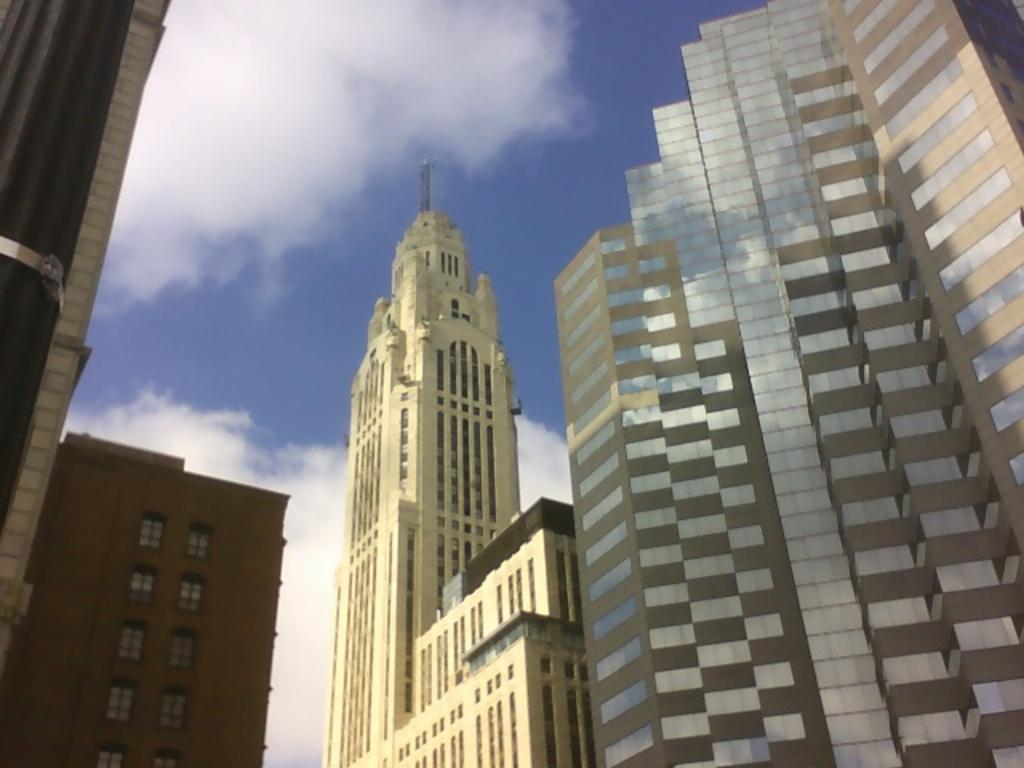What is located in the center of the image? There are buildings in the center of the image. What can be seen in the background of the image? The sky is visible in the background of the image. What type of steel is used to construct the buildings in the image? There is no information provided about the type of steel used in the construction of the buildings in the image. How many fingers can be seen touching the buildings in the image? There are no fingers visible in the image; it only shows the buildings and the sky. 